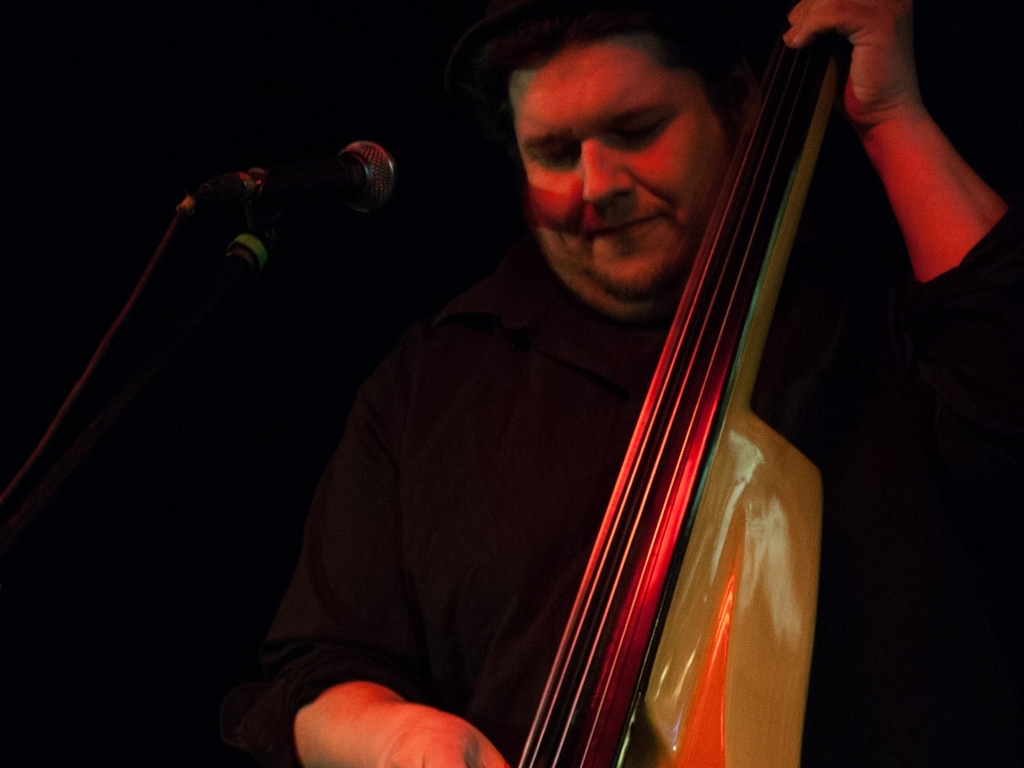What can you tell me about the instrument featured in the image? The image showcases a double bass, which is a stringed instrument primarily used in jazz, classical, and folk music. It has a deep, rich sound and is played either with a bow or by plucking the strings. The musician appears to be engaged with the instrument, implying a dynamic performance. 